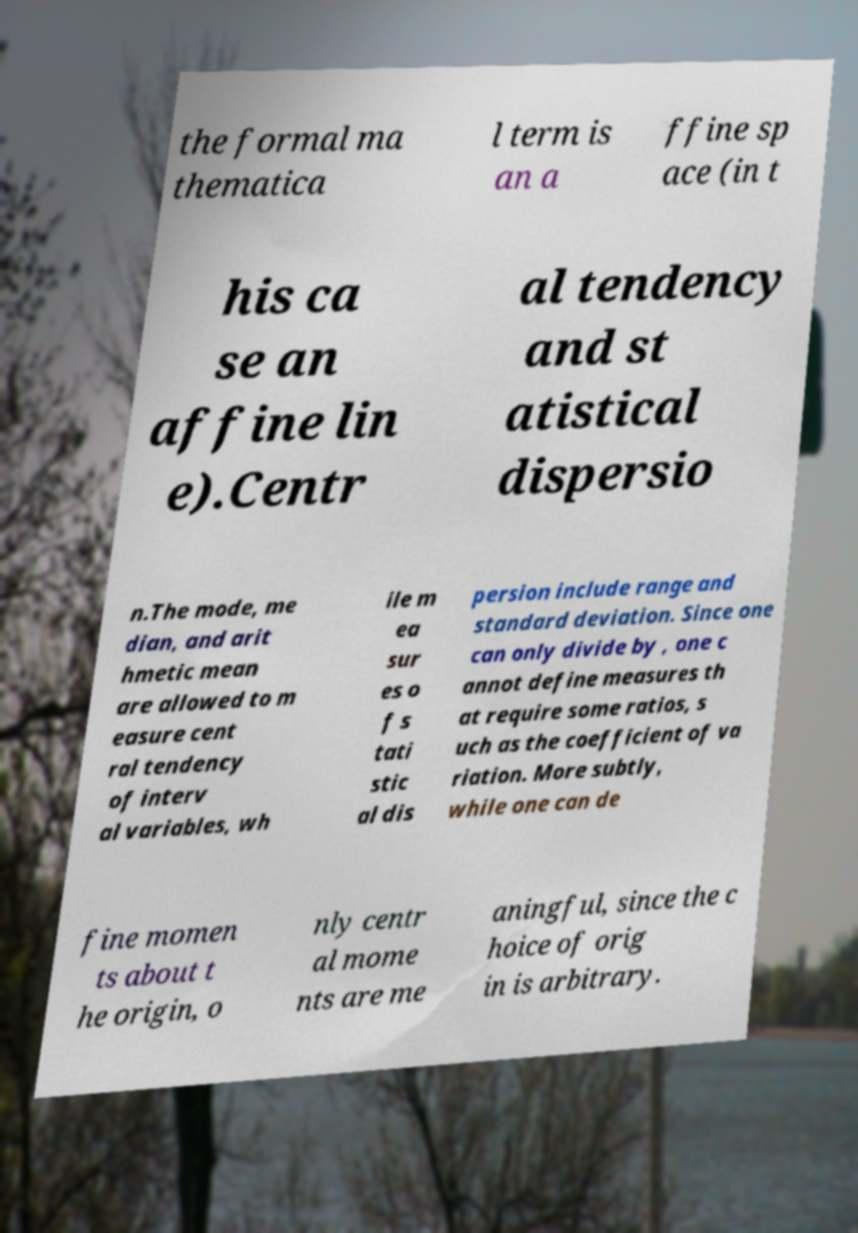Could you assist in decoding the text presented in this image and type it out clearly? the formal ma thematica l term is an a ffine sp ace (in t his ca se an affine lin e).Centr al tendency and st atistical dispersio n.The mode, me dian, and arit hmetic mean are allowed to m easure cent ral tendency of interv al variables, wh ile m ea sur es o f s tati stic al dis persion include range and standard deviation. Since one can only divide by , one c annot define measures th at require some ratios, s uch as the coefficient of va riation. More subtly, while one can de fine momen ts about t he origin, o nly centr al mome nts are me aningful, since the c hoice of orig in is arbitrary. 